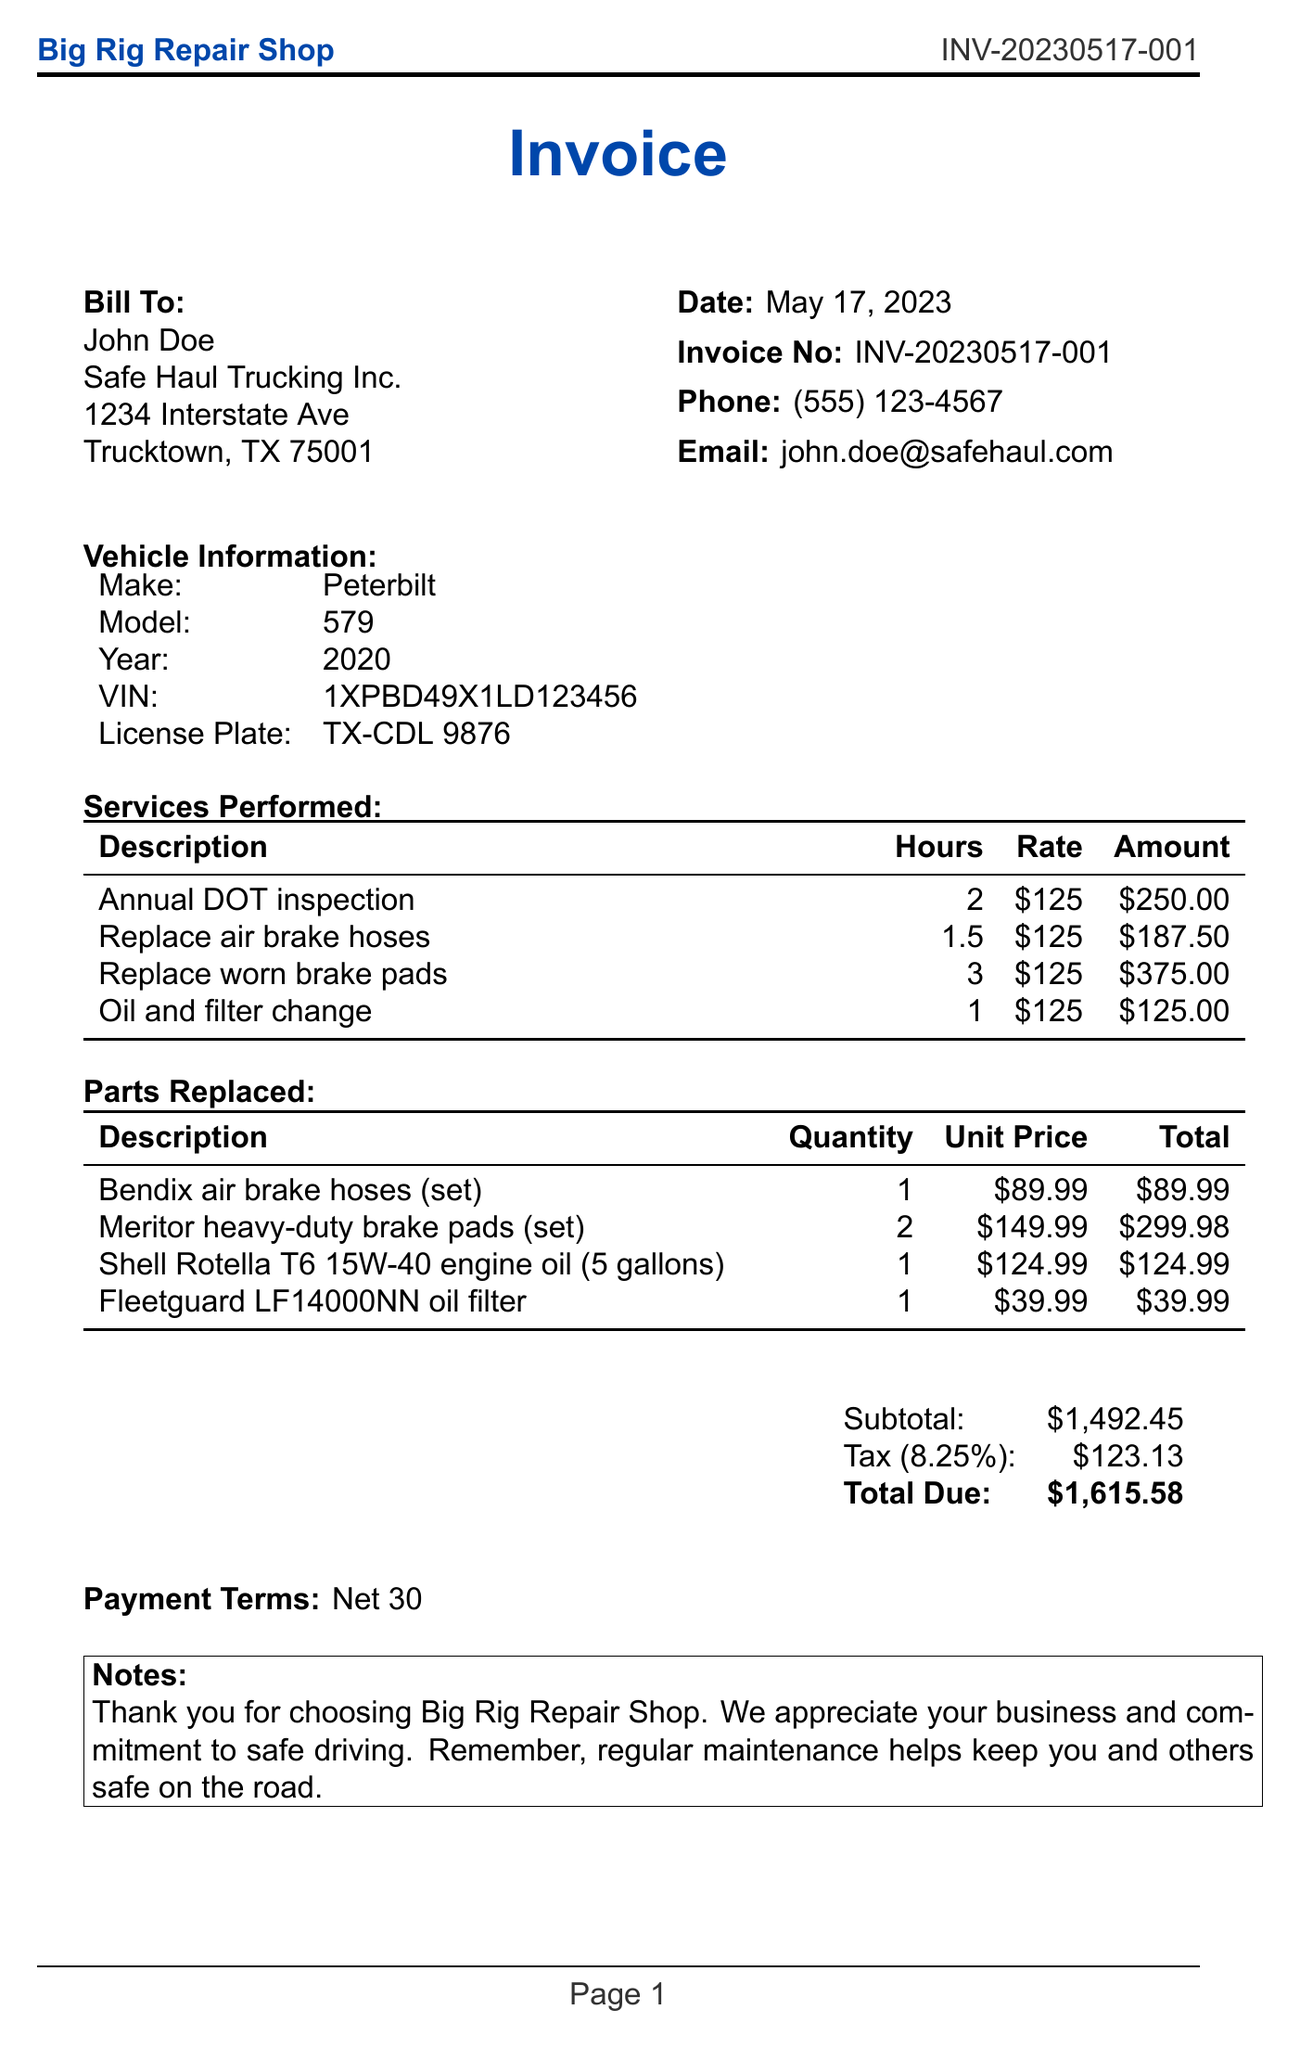What is the invoice number? The invoice number is located at the top right of the document, identifying the specific transaction.
Answer: INV-20230517-001 Who is the customer? The customer's name is mentioned in the billing section of the document.
Answer: John Doe What is the total amount due? The total amount due is calculated at the end of the invoice, including all services and parts.
Answer: $1,615.58 How much is the labor cost for replacing worn brake pads? The labor cost is detailed in the services performed section of the document.
Answer: $375.00 What parts were replaced? The parts replaced section lists all the components that were changed during the service.
Answer: Bendix air brake hoses, Meritor heavy-duty brake pads, Shell Rotella T6 15W-40 engine oil, Fleetguard LF14000NN oil filter How many labor hours were spent on the annual DOT inspection? The labor hours for each service performed are indicated in the services performed section.
Answer: 2 What is the tax rate applied? The tax rate is presented in relation to the subtotal of the invoice.
Answer: 8.25% What is the payment term specified in the invoice? The payment terms are stated clearly towards the end of the document.
Answer: Net 30 What company is the customer associated with? The customer's company name is included in the billing information on the invoice.
Answer: Safe Haul Trucking Inc 